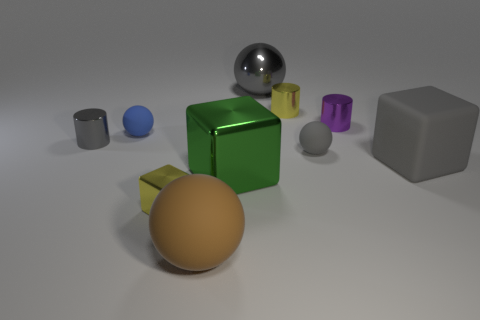What color is the large rubber sphere?
Offer a terse response. Brown. Is the number of tiny cylinders that are left of the brown thing greater than the number of tiny gray spheres left of the yellow cylinder?
Provide a succinct answer. Yes. Is the shape of the small purple object the same as the tiny gray thing that is left of the large green block?
Your response must be concise. Yes. There is a yellow object that is in front of the yellow metallic cylinder; does it have the same size as the cylinder left of the big brown matte ball?
Offer a terse response. Yes. Are there any large gray things right of the big gray object that is in front of the small rubber thing that is behind the gray matte sphere?
Keep it short and to the point. No. Are there fewer big gray cubes on the right side of the tiny cube than gray spheres behind the large green thing?
Ensure brevity in your answer.  Yes. What is the shape of the other large thing that is made of the same material as the green thing?
Ensure brevity in your answer.  Sphere. What size is the gray metal thing that is on the left side of the matte sphere in front of the small sphere in front of the blue object?
Your answer should be very brief. Small. Is the number of red metal cylinders greater than the number of small yellow cylinders?
Offer a terse response. No. There is a large ball on the right side of the brown matte thing; is it the same color as the rubber sphere that is right of the large rubber ball?
Your answer should be very brief. Yes. 